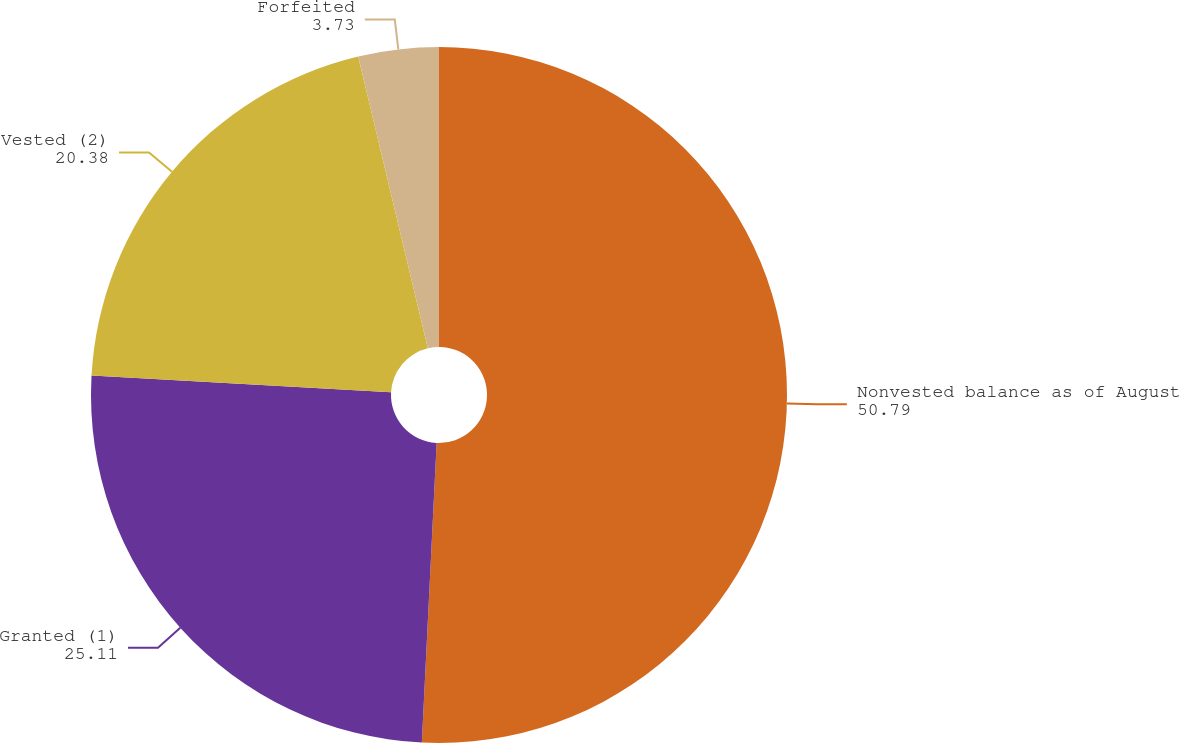Convert chart to OTSL. <chart><loc_0><loc_0><loc_500><loc_500><pie_chart><fcel>Nonvested balance as of August<fcel>Granted (1)<fcel>Vested (2)<fcel>Forfeited<nl><fcel>50.79%<fcel>25.11%<fcel>20.38%<fcel>3.73%<nl></chart> 